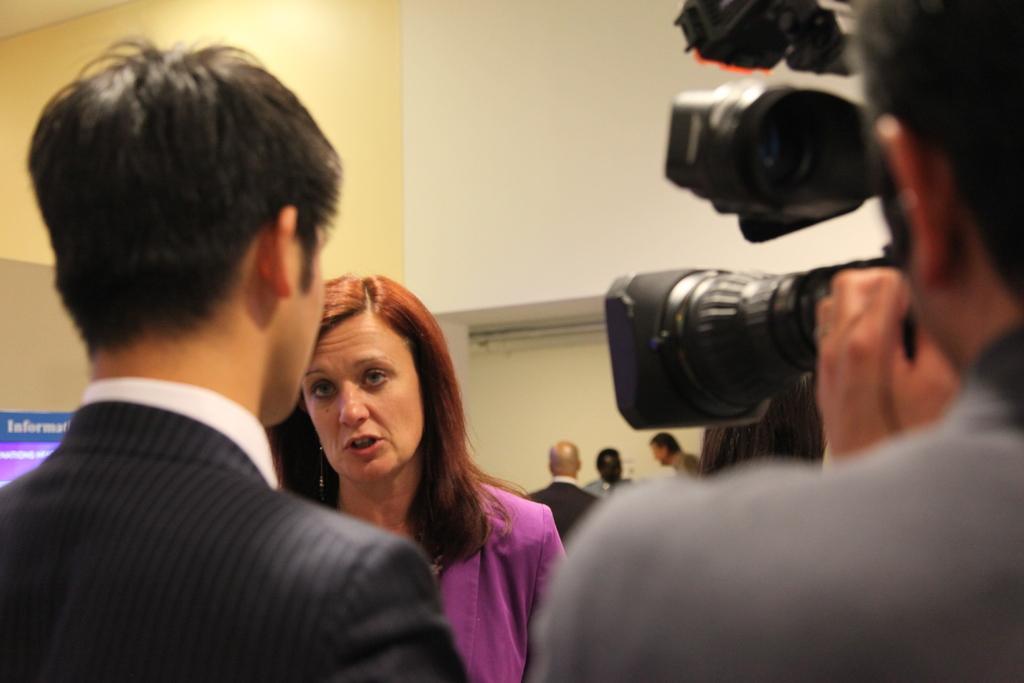Can you describe this image briefly? Here in the middle we can see a woman talking something and in front of her we can see a couple of people Standing and the person on the right side is recording everything with video camera in his hand and behind them we can see people standing 